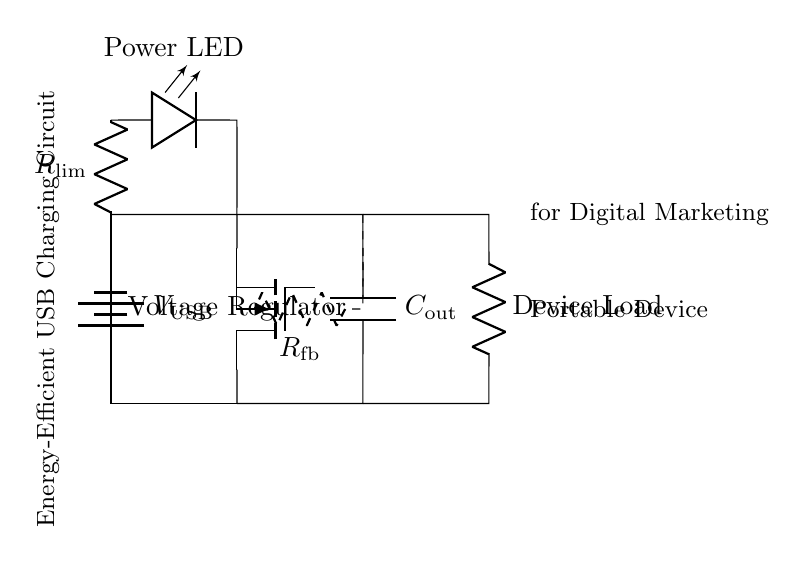What is the main function of the voltage regulator? The voltage regulator stabilizes the output voltage for the portable device so that it operates safely and efficiently at the required voltage level.
Answer: Stabilization What is the value of the current limiting resistor's purpose in this circuit? The current limiting resistor prevents excessive current from flowing into the load or portable device, protecting it from damage while maintaining proper operation.
Answer: Protection What component is used for feedback in this circuit? The feedback loop utilizes the feedback resistor to help regulate the output voltage, ensuring stable operation by providing necessary feedback to the voltage regulator.
Answer: Feedback resistor How many energy-efficient components are in this circuit? The circuit consists of four main components: the voltage regulator, load, feedback resistor, and output capacitor, providing a balanced energy-efficient design for charging devices.
Answer: Four What is the charge storage component in this circuit? The output capacitor stores charge, providing smooth voltage output and compensating for any fluctuations in current demand from the portable device during operation.
Answer: Output capacitor What type of device is this circuit designed to power? The circuit is designed to power low power portable devices, which are typically used for digital marketing activities, enabling artists to promote and sell artwork online efficiently.
Answer: Portable devices 